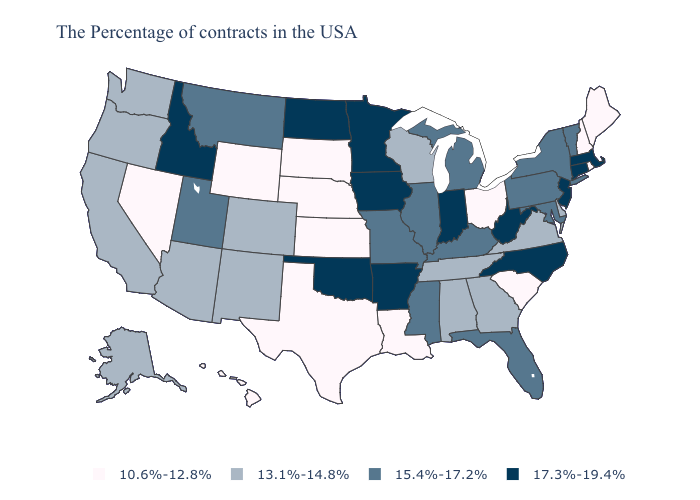Name the states that have a value in the range 17.3%-19.4%?
Concise answer only. Massachusetts, Connecticut, New Jersey, North Carolina, West Virginia, Indiana, Arkansas, Minnesota, Iowa, Oklahoma, North Dakota, Idaho. Name the states that have a value in the range 17.3%-19.4%?
Be succinct. Massachusetts, Connecticut, New Jersey, North Carolina, West Virginia, Indiana, Arkansas, Minnesota, Iowa, Oklahoma, North Dakota, Idaho. Name the states that have a value in the range 13.1%-14.8%?
Quick response, please. Delaware, Virginia, Georgia, Alabama, Tennessee, Wisconsin, Colorado, New Mexico, Arizona, California, Washington, Oregon, Alaska. Name the states that have a value in the range 10.6%-12.8%?
Quick response, please. Maine, Rhode Island, New Hampshire, South Carolina, Ohio, Louisiana, Kansas, Nebraska, Texas, South Dakota, Wyoming, Nevada, Hawaii. What is the value of Pennsylvania?
Be succinct. 15.4%-17.2%. What is the value of Missouri?
Write a very short answer. 15.4%-17.2%. What is the lowest value in the Northeast?
Give a very brief answer. 10.6%-12.8%. What is the value of Vermont?
Short answer required. 15.4%-17.2%. Name the states that have a value in the range 15.4%-17.2%?
Concise answer only. Vermont, New York, Maryland, Pennsylvania, Florida, Michigan, Kentucky, Illinois, Mississippi, Missouri, Utah, Montana. Does Arizona have a lower value than South Carolina?
Keep it brief. No. Name the states that have a value in the range 15.4%-17.2%?
Concise answer only. Vermont, New York, Maryland, Pennsylvania, Florida, Michigan, Kentucky, Illinois, Mississippi, Missouri, Utah, Montana. What is the value of Iowa?
Write a very short answer. 17.3%-19.4%. Does Florida have the highest value in the South?
Be succinct. No. Name the states that have a value in the range 15.4%-17.2%?
Quick response, please. Vermont, New York, Maryland, Pennsylvania, Florida, Michigan, Kentucky, Illinois, Mississippi, Missouri, Utah, Montana. 